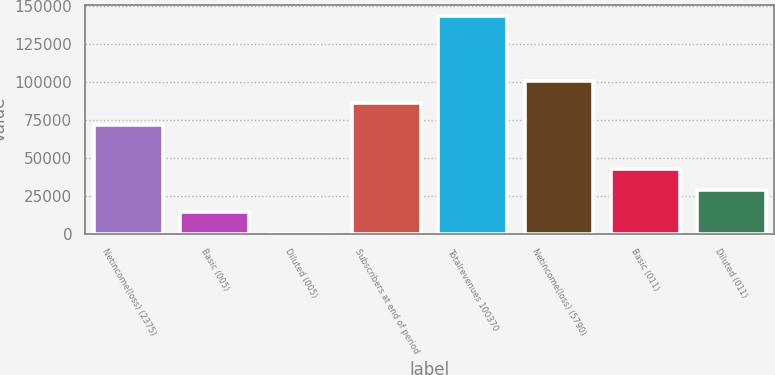Convert chart to OTSL. <chart><loc_0><loc_0><loc_500><loc_500><bar_chart><fcel>Netincome(loss) (2375)<fcel>Basic (005)<fcel>Diluted (005)<fcel>Subscribers at end of period<fcel>Totalrevenues 100370<fcel>Netincome(loss) (5790)<fcel>Basic (011)<fcel>Diluted (011)<nl><fcel>71946.5<fcel>14389.3<fcel>0.04<fcel>86335.8<fcel>143893<fcel>100725<fcel>43167.9<fcel>28778.6<nl></chart> 